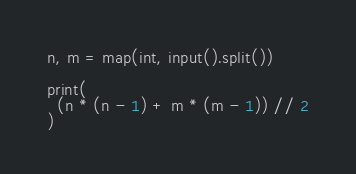<code> <loc_0><loc_0><loc_500><loc_500><_Python_>n, m = map(int, input().split())
 
print(
  (n * (n - 1) + m * (m - 1)) // 2
)</code> 